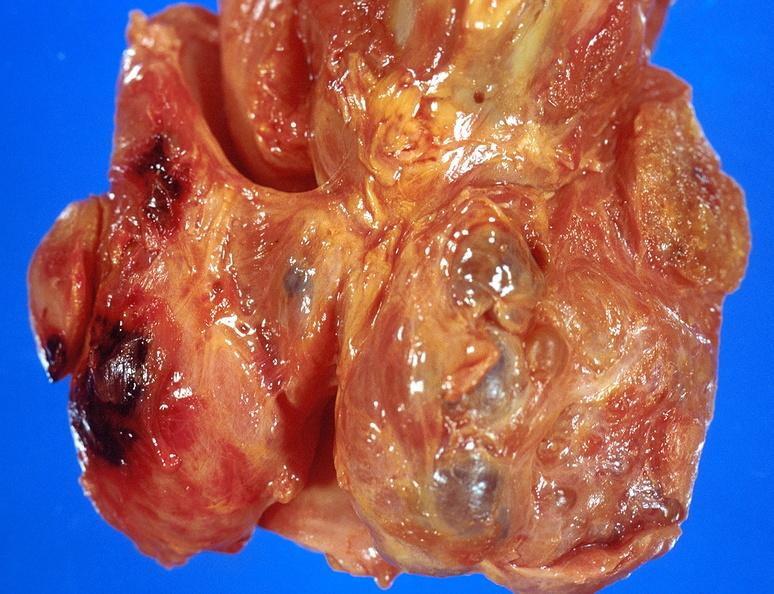s endocrine present?
Answer the question using a single word or phrase. Yes 